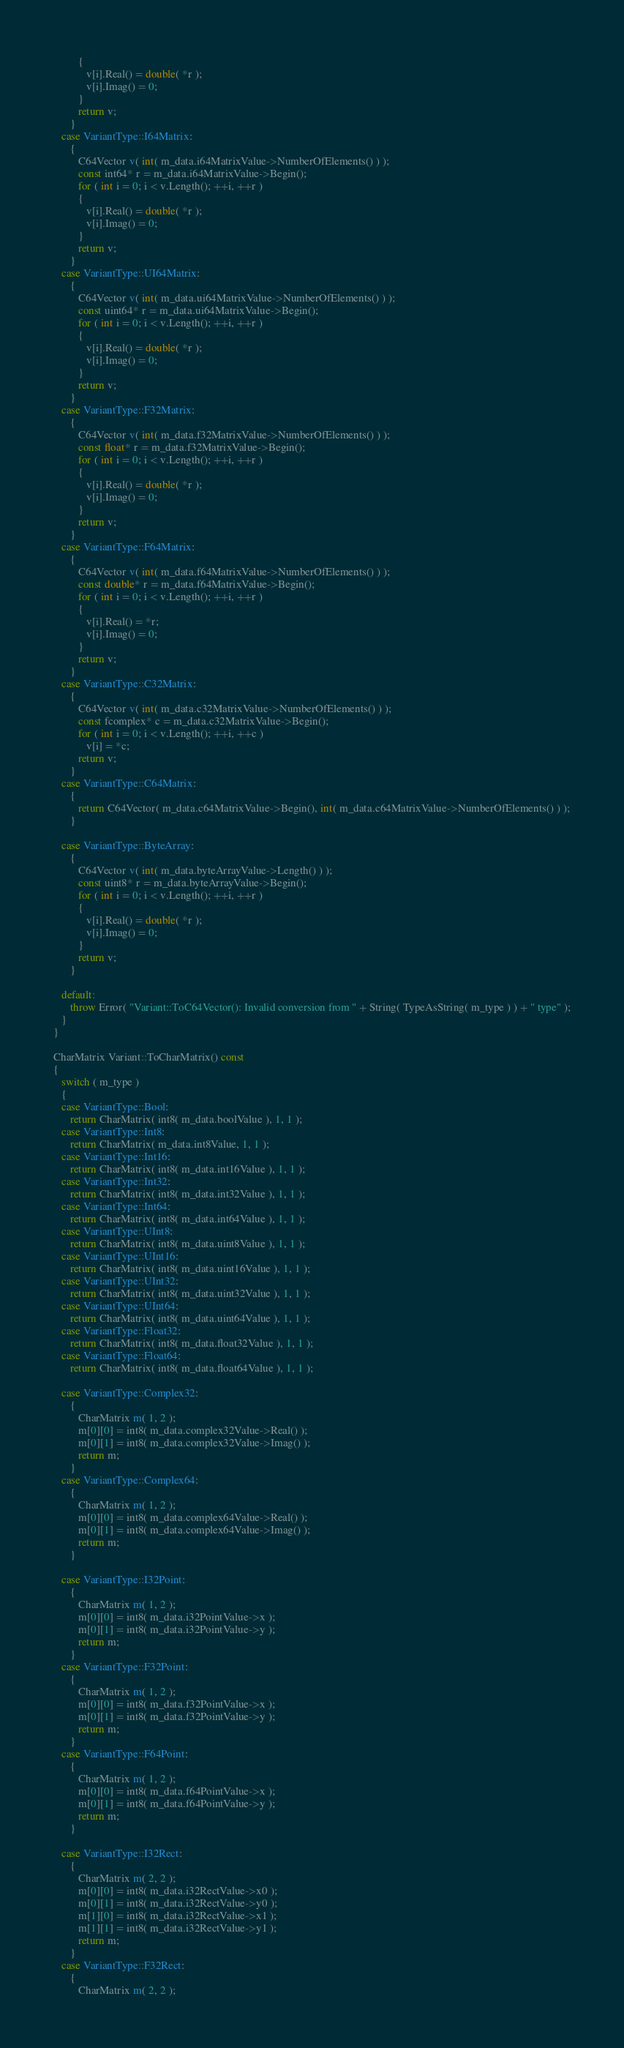Convert code to text. <code><loc_0><loc_0><loc_500><loc_500><_C++_>         {
            v[i].Real() = double( *r );
            v[i].Imag() = 0;
         }
         return v;
      }
   case VariantType::I64Matrix:
      {
         C64Vector v( int( m_data.i64MatrixValue->NumberOfElements() ) );
         const int64* r = m_data.i64MatrixValue->Begin();
         for ( int i = 0; i < v.Length(); ++i, ++r )
         {
            v[i].Real() = double( *r );
            v[i].Imag() = 0;
         }
         return v;
      }
   case VariantType::UI64Matrix:
      {
         C64Vector v( int( m_data.ui64MatrixValue->NumberOfElements() ) );
         const uint64* r = m_data.ui64MatrixValue->Begin();
         for ( int i = 0; i < v.Length(); ++i, ++r )
         {
            v[i].Real() = double( *r );
            v[i].Imag() = 0;
         }
         return v;
      }
   case VariantType::F32Matrix:
      {
         C64Vector v( int( m_data.f32MatrixValue->NumberOfElements() ) );
         const float* r = m_data.f32MatrixValue->Begin();
         for ( int i = 0; i < v.Length(); ++i, ++r )
         {
            v[i].Real() = double( *r );
            v[i].Imag() = 0;
         }
         return v;
      }
   case VariantType::F64Matrix:
      {
         C64Vector v( int( m_data.f64MatrixValue->NumberOfElements() ) );
         const double* r = m_data.f64MatrixValue->Begin();
         for ( int i = 0; i < v.Length(); ++i, ++r )
         {
            v[i].Real() = *r;
            v[i].Imag() = 0;
         }
         return v;
      }
   case VariantType::C32Matrix:
      {
         C64Vector v( int( m_data.c32MatrixValue->NumberOfElements() ) );
         const fcomplex* c = m_data.c32MatrixValue->Begin();
         for ( int i = 0; i < v.Length(); ++i, ++c )
            v[i] = *c;
         return v;
      }
   case VariantType::C64Matrix:
      {
         return C64Vector( m_data.c64MatrixValue->Begin(), int( m_data.c64MatrixValue->NumberOfElements() ) );
      }

   case VariantType::ByteArray:
      {
         C64Vector v( int( m_data.byteArrayValue->Length() ) );
         const uint8* r = m_data.byteArrayValue->Begin();
         for ( int i = 0; i < v.Length(); ++i, ++r )
         {
            v[i].Real() = double( *r );
            v[i].Imag() = 0;
         }
         return v;
      }

   default:
      throw Error( "Variant::ToC64Vector(): Invalid conversion from " + String( TypeAsString( m_type ) ) + " type" );
   }
}

CharMatrix Variant::ToCharMatrix() const
{
   switch ( m_type )
   {
   case VariantType::Bool:
      return CharMatrix( int8( m_data.boolValue ), 1, 1 );
   case VariantType::Int8:
      return CharMatrix( m_data.int8Value, 1, 1 );
   case VariantType::Int16:
      return CharMatrix( int8( m_data.int16Value ), 1, 1 );
   case VariantType::Int32:
      return CharMatrix( int8( m_data.int32Value ), 1, 1 );
   case VariantType::Int64:
      return CharMatrix( int8( m_data.int64Value ), 1, 1 );
   case VariantType::UInt8:
      return CharMatrix( int8( m_data.uint8Value ), 1, 1 );
   case VariantType::UInt16:
      return CharMatrix( int8( m_data.uint16Value ), 1, 1 );
   case VariantType::UInt32:
      return CharMatrix( int8( m_data.uint32Value ), 1, 1 );
   case VariantType::UInt64:
      return CharMatrix( int8( m_data.uint64Value ), 1, 1 );
   case VariantType::Float32:
      return CharMatrix( int8( m_data.float32Value ), 1, 1 );
   case VariantType::Float64:
      return CharMatrix( int8( m_data.float64Value ), 1, 1 );

   case VariantType::Complex32:
      {
         CharMatrix m( 1, 2 );
         m[0][0] = int8( m_data.complex32Value->Real() );
         m[0][1] = int8( m_data.complex32Value->Imag() );
         return m;
      }
   case VariantType::Complex64:
      {
         CharMatrix m( 1, 2 );
         m[0][0] = int8( m_data.complex64Value->Real() );
         m[0][1] = int8( m_data.complex64Value->Imag() );
         return m;
      }

   case VariantType::I32Point:
      {
         CharMatrix m( 1, 2 );
         m[0][0] = int8( m_data.i32PointValue->x );
         m[0][1] = int8( m_data.i32PointValue->y );
         return m;
      }
   case VariantType::F32Point:
      {
         CharMatrix m( 1, 2 );
         m[0][0] = int8( m_data.f32PointValue->x );
         m[0][1] = int8( m_data.f32PointValue->y );
         return m;
      }
   case VariantType::F64Point:
      {
         CharMatrix m( 1, 2 );
         m[0][0] = int8( m_data.f64PointValue->x );
         m[0][1] = int8( m_data.f64PointValue->y );
         return m;
      }

   case VariantType::I32Rect:
      {
         CharMatrix m( 2, 2 );
         m[0][0] = int8( m_data.i32RectValue->x0 );
         m[0][1] = int8( m_data.i32RectValue->y0 );
         m[1][0] = int8( m_data.i32RectValue->x1 );
         m[1][1] = int8( m_data.i32RectValue->y1 );
         return m;
      }
   case VariantType::F32Rect:
      {
         CharMatrix m( 2, 2 );</code> 